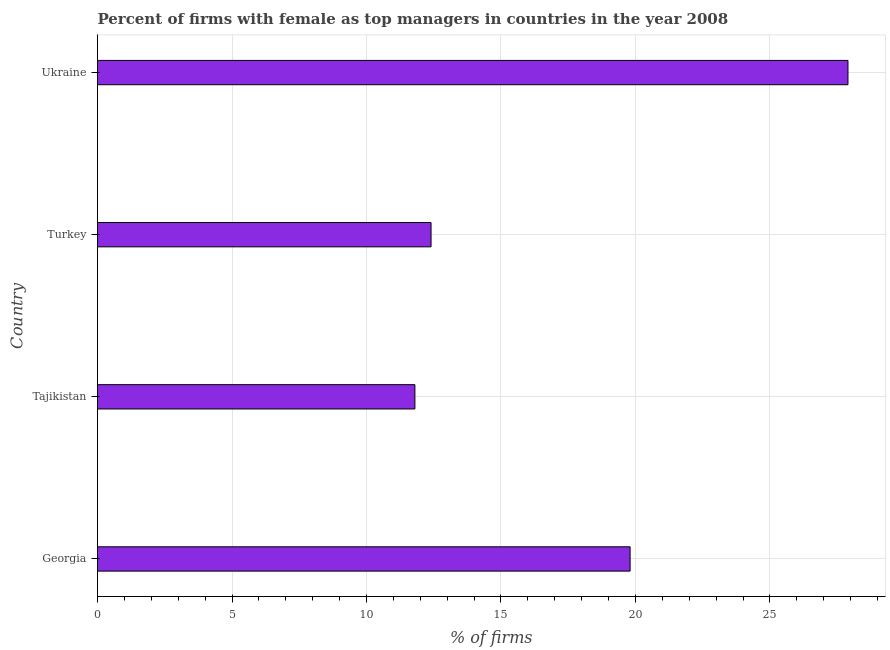Does the graph contain any zero values?
Keep it short and to the point. No. What is the title of the graph?
Provide a short and direct response. Percent of firms with female as top managers in countries in the year 2008. What is the label or title of the X-axis?
Offer a terse response. % of firms. What is the percentage of firms with female as top manager in Turkey?
Your response must be concise. 12.4. Across all countries, what is the maximum percentage of firms with female as top manager?
Provide a short and direct response. 27.9. Across all countries, what is the minimum percentage of firms with female as top manager?
Provide a succinct answer. 11.8. In which country was the percentage of firms with female as top manager maximum?
Offer a very short reply. Ukraine. In which country was the percentage of firms with female as top manager minimum?
Provide a succinct answer. Tajikistan. What is the sum of the percentage of firms with female as top manager?
Offer a terse response. 71.9. What is the average percentage of firms with female as top manager per country?
Keep it short and to the point. 17.98. In how many countries, is the percentage of firms with female as top manager greater than 17 %?
Your answer should be compact. 2. What is the ratio of the percentage of firms with female as top manager in Georgia to that in Turkey?
Your answer should be compact. 1.6. Is the percentage of firms with female as top manager in Tajikistan less than that in Turkey?
Your answer should be very brief. Yes. Is the difference between the percentage of firms with female as top manager in Tajikistan and Turkey greater than the difference between any two countries?
Provide a succinct answer. No. What is the difference between the highest and the second highest percentage of firms with female as top manager?
Keep it short and to the point. 8.1. How many countries are there in the graph?
Keep it short and to the point. 4. Are the values on the major ticks of X-axis written in scientific E-notation?
Your response must be concise. No. What is the % of firms in Georgia?
Provide a short and direct response. 19.8. What is the % of firms of Turkey?
Give a very brief answer. 12.4. What is the % of firms of Ukraine?
Your answer should be compact. 27.9. What is the difference between the % of firms in Georgia and Tajikistan?
Offer a terse response. 8. What is the difference between the % of firms in Georgia and Ukraine?
Your answer should be compact. -8.1. What is the difference between the % of firms in Tajikistan and Ukraine?
Your answer should be very brief. -16.1. What is the difference between the % of firms in Turkey and Ukraine?
Make the answer very short. -15.5. What is the ratio of the % of firms in Georgia to that in Tajikistan?
Give a very brief answer. 1.68. What is the ratio of the % of firms in Georgia to that in Turkey?
Offer a terse response. 1.6. What is the ratio of the % of firms in Georgia to that in Ukraine?
Make the answer very short. 0.71. What is the ratio of the % of firms in Tajikistan to that in Ukraine?
Offer a very short reply. 0.42. What is the ratio of the % of firms in Turkey to that in Ukraine?
Make the answer very short. 0.44. 